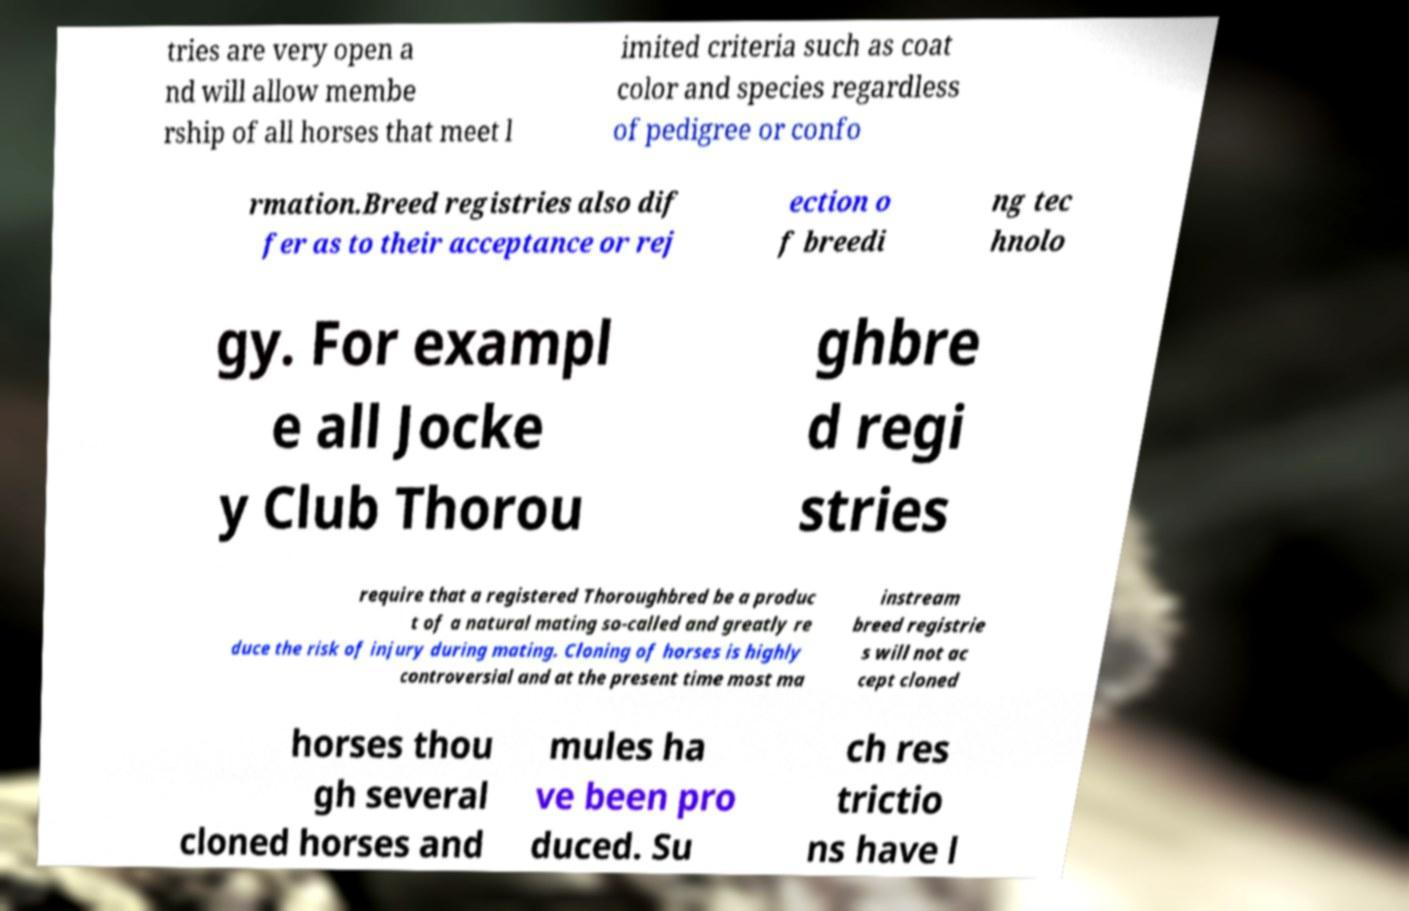There's text embedded in this image that I need extracted. Can you transcribe it verbatim? tries are very open a nd will allow membe rship of all horses that meet l imited criteria such as coat color and species regardless of pedigree or confo rmation.Breed registries also dif fer as to their acceptance or rej ection o f breedi ng tec hnolo gy. For exampl e all Jocke y Club Thorou ghbre d regi stries require that a registered Thoroughbred be a produc t of a natural mating so-called and greatly re duce the risk of injury during mating. Cloning of horses is highly controversial and at the present time most ma instream breed registrie s will not ac cept cloned horses thou gh several cloned horses and mules ha ve been pro duced. Su ch res trictio ns have l 